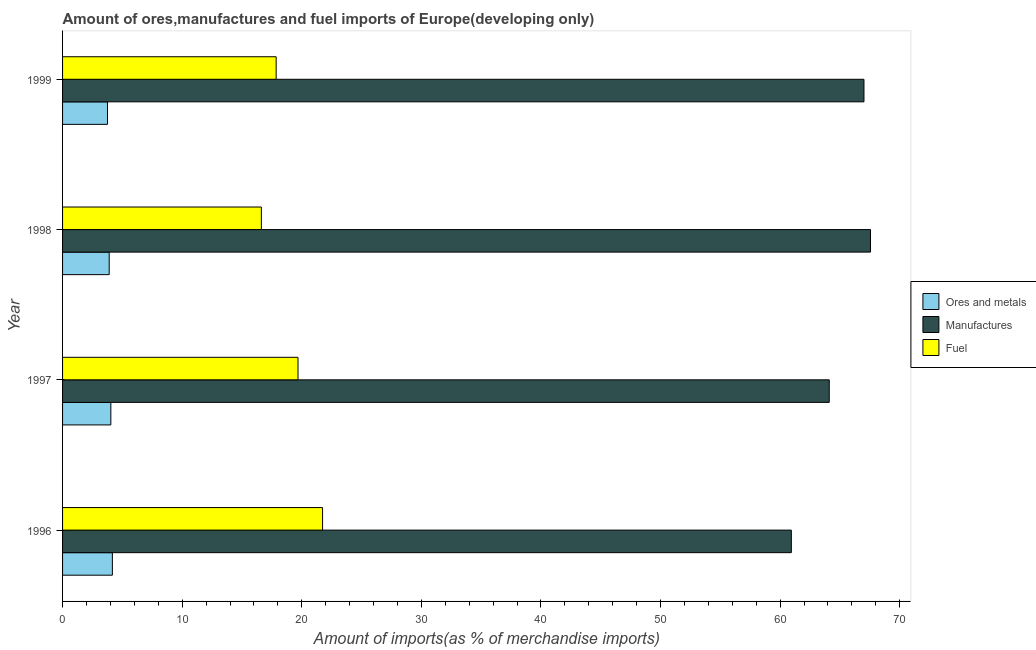How many different coloured bars are there?
Provide a succinct answer. 3. Are the number of bars per tick equal to the number of legend labels?
Provide a short and direct response. Yes. How many bars are there on the 2nd tick from the bottom?
Give a very brief answer. 3. What is the label of the 1st group of bars from the top?
Keep it short and to the point. 1999. What is the percentage of manufactures imports in 1999?
Make the answer very short. 67.01. Across all years, what is the maximum percentage of manufactures imports?
Your answer should be compact. 67.56. Across all years, what is the minimum percentage of ores and metals imports?
Give a very brief answer. 3.76. In which year was the percentage of manufactures imports maximum?
Provide a short and direct response. 1998. In which year was the percentage of manufactures imports minimum?
Keep it short and to the point. 1996. What is the total percentage of ores and metals imports in the graph?
Your answer should be compact. 15.86. What is the difference between the percentage of ores and metals imports in 1996 and that in 1998?
Your answer should be compact. 0.27. What is the difference between the percentage of ores and metals imports in 1998 and the percentage of fuel imports in 1997?
Make the answer very short. -15.79. What is the average percentage of manufactures imports per year?
Your answer should be compact. 64.9. In the year 1998, what is the difference between the percentage of manufactures imports and percentage of fuel imports?
Ensure brevity in your answer.  50.93. What is the ratio of the percentage of ores and metals imports in 1997 to that in 1999?
Offer a terse response. 1.07. Is the difference between the percentage of fuel imports in 1996 and 1997 greater than the difference between the percentage of ores and metals imports in 1996 and 1997?
Offer a terse response. Yes. What is the difference between the highest and the second highest percentage of fuel imports?
Make the answer very short. 2.05. What is the difference between the highest and the lowest percentage of manufactures imports?
Offer a terse response. 6.62. In how many years, is the percentage of ores and metals imports greater than the average percentage of ores and metals imports taken over all years?
Provide a short and direct response. 2. Is the sum of the percentage of manufactures imports in 1996 and 1997 greater than the maximum percentage of ores and metals imports across all years?
Your answer should be compact. Yes. What does the 1st bar from the top in 1997 represents?
Provide a short and direct response. Fuel. What does the 1st bar from the bottom in 1997 represents?
Provide a succinct answer. Ores and metals. How many years are there in the graph?
Provide a short and direct response. 4. Are the values on the major ticks of X-axis written in scientific E-notation?
Your response must be concise. No. Does the graph contain grids?
Offer a terse response. No. Where does the legend appear in the graph?
Offer a terse response. Center right. How are the legend labels stacked?
Provide a succinct answer. Vertical. What is the title of the graph?
Make the answer very short. Amount of ores,manufactures and fuel imports of Europe(developing only). What is the label or title of the X-axis?
Ensure brevity in your answer.  Amount of imports(as % of merchandise imports). What is the Amount of imports(as % of merchandise imports) of Ores and metals in 1996?
Your answer should be very brief. 4.16. What is the Amount of imports(as % of merchandise imports) of Manufactures in 1996?
Keep it short and to the point. 60.94. What is the Amount of imports(as % of merchandise imports) in Fuel in 1996?
Your response must be concise. 21.74. What is the Amount of imports(as % of merchandise imports) in Ores and metals in 1997?
Keep it short and to the point. 4.04. What is the Amount of imports(as % of merchandise imports) in Manufactures in 1997?
Give a very brief answer. 64.11. What is the Amount of imports(as % of merchandise imports) of Fuel in 1997?
Give a very brief answer. 19.69. What is the Amount of imports(as % of merchandise imports) in Ores and metals in 1998?
Your answer should be compact. 3.9. What is the Amount of imports(as % of merchandise imports) of Manufactures in 1998?
Give a very brief answer. 67.56. What is the Amount of imports(as % of merchandise imports) of Fuel in 1998?
Provide a succinct answer. 16.62. What is the Amount of imports(as % of merchandise imports) in Ores and metals in 1999?
Keep it short and to the point. 3.76. What is the Amount of imports(as % of merchandise imports) in Manufactures in 1999?
Offer a terse response. 67.01. What is the Amount of imports(as % of merchandise imports) in Fuel in 1999?
Ensure brevity in your answer.  17.86. Across all years, what is the maximum Amount of imports(as % of merchandise imports) of Ores and metals?
Offer a very short reply. 4.16. Across all years, what is the maximum Amount of imports(as % of merchandise imports) of Manufactures?
Your answer should be very brief. 67.56. Across all years, what is the maximum Amount of imports(as % of merchandise imports) of Fuel?
Your response must be concise. 21.74. Across all years, what is the minimum Amount of imports(as % of merchandise imports) in Ores and metals?
Your response must be concise. 3.76. Across all years, what is the minimum Amount of imports(as % of merchandise imports) in Manufactures?
Offer a very short reply. 60.94. Across all years, what is the minimum Amount of imports(as % of merchandise imports) in Fuel?
Make the answer very short. 16.62. What is the total Amount of imports(as % of merchandise imports) in Ores and metals in the graph?
Your response must be concise. 15.86. What is the total Amount of imports(as % of merchandise imports) in Manufactures in the graph?
Provide a succinct answer. 259.61. What is the total Amount of imports(as % of merchandise imports) of Fuel in the graph?
Your answer should be very brief. 75.91. What is the difference between the Amount of imports(as % of merchandise imports) in Ores and metals in 1996 and that in 1997?
Your response must be concise. 0.13. What is the difference between the Amount of imports(as % of merchandise imports) in Manufactures in 1996 and that in 1997?
Keep it short and to the point. -3.17. What is the difference between the Amount of imports(as % of merchandise imports) in Fuel in 1996 and that in 1997?
Ensure brevity in your answer.  2.05. What is the difference between the Amount of imports(as % of merchandise imports) of Ores and metals in 1996 and that in 1998?
Provide a short and direct response. 0.27. What is the difference between the Amount of imports(as % of merchandise imports) in Manufactures in 1996 and that in 1998?
Offer a terse response. -6.62. What is the difference between the Amount of imports(as % of merchandise imports) in Fuel in 1996 and that in 1998?
Your answer should be compact. 5.12. What is the difference between the Amount of imports(as % of merchandise imports) in Ores and metals in 1996 and that in 1999?
Make the answer very short. 0.41. What is the difference between the Amount of imports(as % of merchandise imports) of Manufactures in 1996 and that in 1999?
Give a very brief answer. -6.07. What is the difference between the Amount of imports(as % of merchandise imports) in Fuel in 1996 and that in 1999?
Make the answer very short. 3.88. What is the difference between the Amount of imports(as % of merchandise imports) in Ores and metals in 1997 and that in 1998?
Your answer should be very brief. 0.14. What is the difference between the Amount of imports(as % of merchandise imports) of Manufactures in 1997 and that in 1998?
Your answer should be compact. -3.45. What is the difference between the Amount of imports(as % of merchandise imports) of Fuel in 1997 and that in 1998?
Give a very brief answer. 3.06. What is the difference between the Amount of imports(as % of merchandise imports) in Ores and metals in 1997 and that in 1999?
Provide a succinct answer. 0.28. What is the difference between the Amount of imports(as % of merchandise imports) in Manufactures in 1997 and that in 1999?
Your response must be concise. -2.9. What is the difference between the Amount of imports(as % of merchandise imports) of Fuel in 1997 and that in 1999?
Your answer should be very brief. 1.83. What is the difference between the Amount of imports(as % of merchandise imports) in Ores and metals in 1998 and that in 1999?
Your answer should be compact. 0.14. What is the difference between the Amount of imports(as % of merchandise imports) in Manufactures in 1998 and that in 1999?
Keep it short and to the point. 0.55. What is the difference between the Amount of imports(as % of merchandise imports) in Fuel in 1998 and that in 1999?
Your response must be concise. -1.24. What is the difference between the Amount of imports(as % of merchandise imports) of Ores and metals in 1996 and the Amount of imports(as % of merchandise imports) of Manufactures in 1997?
Provide a succinct answer. -59.94. What is the difference between the Amount of imports(as % of merchandise imports) of Ores and metals in 1996 and the Amount of imports(as % of merchandise imports) of Fuel in 1997?
Your answer should be very brief. -15.52. What is the difference between the Amount of imports(as % of merchandise imports) in Manufactures in 1996 and the Amount of imports(as % of merchandise imports) in Fuel in 1997?
Provide a succinct answer. 41.25. What is the difference between the Amount of imports(as % of merchandise imports) of Ores and metals in 1996 and the Amount of imports(as % of merchandise imports) of Manufactures in 1998?
Offer a terse response. -63.39. What is the difference between the Amount of imports(as % of merchandise imports) of Ores and metals in 1996 and the Amount of imports(as % of merchandise imports) of Fuel in 1998?
Ensure brevity in your answer.  -12.46. What is the difference between the Amount of imports(as % of merchandise imports) of Manufactures in 1996 and the Amount of imports(as % of merchandise imports) of Fuel in 1998?
Offer a very short reply. 44.31. What is the difference between the Amount of imports(as % of merchandise imports) of Ores and metals in 1996 and the Amount of imports(as % of merchandise imports) of Manufactures in 1999?
Provide a succinct answer. -62.84. What is the difference between the Amount of imports(as % of merchandise imports) of Ores and metals in 1996 and the Amount of imports(as % of merchandise imports) of Fuel in 1999?
Ensure brevity in your answer.  -13.7. What is the difference between the Amount of imports(as % of merchandise imports) in Manufactures in 1996 and the Amount of imports(as % of merchandise imports) in Fuel in 1999?
Your answer should be compact. 43.08. What is the difference between the Amount of imports(as % of merchandise imports) in Ores and metals in 1997 and the Amount of imports(as % of merchandise imports) in Manufactures in 1998?
Give a very brief answer. -63.52. What is the difference between the Amount of imports(as % of merchandise imports) of Ores and metals in 1997 and the Amount of imports(as % of merchandise imports) of Fuel in 1998?
Provide a short and direct response. -12.59. What is the difference between the Amount of imports(as % of merchandise imports) of Manufactures in 1997 and the Amount of imports(as % of merchandise imports) of Fuel in 1998?
Keep it short and to the point. 47.48. What is the difference between the Amount of imports(as % of merchandise imports) of Ores and metals in 1997 and the Amount of imports(as % of merchandise imports) of Manufactures in 1999?
Your answer should be very brief. -62.97. What is the difference between the Amount of imports(as % of merchandise imports) in Ores and metals in 1997 and the Amount of imports(as % of merchandise imports) in Fuel in 1999?
Offer a very short reply. -13.82. What is the difference between the Amount of imports(as % of merchandise imports) of Manufactures in 1997 and the Amount of imports(as % of merchandise imports) of Fuel in 1999?
Make the answer very short. 46.25. What is the difference between the Amount of imports(as % of merchandise imports) in Ores and metals in 1998 and the Amount of imports(as % of merchandise imports) in Manufactures in 1999?
Offer a terse response. -63.11. What is the difference between the Amount of imports(as % of merchandise imports) in Ores and metals in 1998 and the Amount of imports(as % of merchandise imports) in Fuel in 1999?
Give a very brief answer. -13.96. What is the difference between the Amount of imports(as % of merchandise imports) in Manufactures in 1998 and the Amount of imports(as % of merchandise imports) in Fuel in 1999?
Your response must be concise. 49.7. What is the average Amount of imports(as % of merchandise imports) of Ores and metals per year?
Provide a succinct answer. 3.96. What is the average Amount of imports(as % of merchandise imports) of Manufactures per year?
Give a very brief answer. 64.9. What is the average Amount of imports(as % of merchandise imports) in Fuel per year?
Offer a terse response. 18.98. In the year 1996, what is the difference between the Amount of imports(as % of merchandise imports) of Ores and metals and Amount of imports(as % of merchandise imports) of Manufactures?
Your answer should be very brief. -56.77. In the year 1996, what is the difference between the Amount of imports(as % of merchandise imports) in Ores and metals and Amount of imports(as % of merchandise imports) in Fuel?
Your answer should be compact. -17.57. In the year 1996, what is the difference between the Amount of imports(as % of merchandise imports) in Manufactures and Amount of imports(as % of merchandise imports) in Fuel?
Offer a terse response. 39.2. In the year 1997, what is the difference between the Amount of imports(as % of merchandise imports) in Ores and metals and Amount of imports(as % of merchandise imports) in Manufactures?
Keep it short and to the point. -60.07. In the year 1997, what is the difference between the Amount of imports(as % of merchandise imports) in Ores and metals and Amount of imports(as % of merchandise imports) in Fuel?
Provide a succinct answer. -15.65. In the year 1997, what is the difference between the Amount of imports(as % of merchandise imports) of Manufactures and Amount of imports(as % of merchandise imports) of Fuel?
Keep it short and to the point. 44.42. In the year 1998, what is the difference between the Amount of imports(as % of merchandise imports) of Ores and metals and Amount of imports(as % of merchandise imports) of Manufactures?
Offer a very short reply. -63.66. In the year 1998, what is the difference between the Amount of imports(as % of merchandise imports) in Ores and metals and Amount of imports(as % of merchandise imports) in Fuel?
Provide a succinct answer. -12.72. In the year 1998, what is the difference between the Amount of imports(as % of merchandise imports) of Manufactures and Amount of imports(as % of merchandise imports) of Fuel?
Offer a very short reply. 50.93. In the year 1999, what is the difference between the Amount of imports(as % of merchandise imports) in Ores and metals and Amount of imports(as % of merchandise imports) in Manufactures?
Your answer should be very brief. -63.25. In the year 1999, what is the difference between the Amount of imports(as % of merchandise imports) of Ores and metals and Amount of imports(as % of merchandise imports) of Fuel?
Keep it short and to the point. -14.1. In the year 1999, what is the difference between the Amount of imports(as % of merchandise imports) of Manufactures and Amount of imports(as % of merchandise imports) of Fuel?
Provide a succinct answer. 49.15. What is the ratio of the Amount of imports(as % of merchandise imports) in Ores and metals in 1996 to that in 1997?
Keep it short and to the point. 1.03. What is the ratio of the Amount of imports(as % of merchandise imports) in Manufactures in 1996 to that in 1997?
Keep it short and to the point. 0.95. What is the ratio of the Amount of imports(as % of merchandise imports) in Fuel in 1996 to that in 1997?
Provide a short and direct response. 1.1. What is the ratio of the Amount of imports(as % of merchandise imports) of Ores and metals in 1996 to that in 1998?
Keep it short and to the point. 1.07. What is the ratio of the Amount of imports(as % of merchandise imports) of Manufactures in 1996 to that in 1998?
Keep it short and to the point. 0.9. What is the ratio of the Amount of imports(as % of merchandise imports) of Fuel in 1996 to that in 1998?
Give a very brief answer. 1.31. What is the ratio of the Amount of imports(as % of merchandise imports) in Ores and metals in 1996 to that in 1999?
Ensure brevity in your answer.  1.11. What is the ratio of the Amount of imports(as % of merchandise imports) of Manufactures in 1996 to that in 1999?
Keep it short and to the point. 0.91. What is the ratio of the Amount of imports(as % of merchandise imports) in Fuel in 1996 to that in 1999?
Provide a short and direct response. 1.22. What is the ratio of the Amount of imports(as % of merchandise imports) in Ores and metals in 1997 to that in 1998?
Give a very brief answer. 1.04. What is the ratio of the Amount of imports(as % of merchandise imports) of Manufactures in 1997 to that in 1998?
Provide a succinct answer. 0.95. What is the ratio of the Amount of imports(as % of merchandise imports) in Fuel in 1997 to that in 1998?
Offer a very short reply. 1.18. What is the ratio of the Amount of imports(as % of merchandise imports) in Ores and metals in 1997 to that in 1999?
Your response must be concise. 1.07. What is the ratio of the Amount of imports(as % of merchandise imports) of Manufactures in 1997 to that in 1999?
Keep it short and to the point. 0.96. What is the ratio of the Amount of imports(as % of merchandise imports) in Fuel in 1997 to that in 1999?
Your response must be concise. 1.1. What is the ratio of the Amount of imports(as % of merchandise imports) of Ores and metals in 1998 to that in 1999?
Offer a terse response. 1.04. What is the ratio of the Amount of imports(as % of merchandise imports) in Manufactures in 1998 to that in 1999?
Offer a terse response. 1.01. What is the ratio of the Amount of imports(as % of merchandise imports) of Fuel in 1998 to that in 1999?
Your answer should be very brief. 0.93. What is the difference between the highest and the second highest Amount of imports(as % of merchandise imports) in Ores and metals?
Your answer should be compact. 0.13. What is the difference between the highest and the second highest Amount of imports(as % of merchandise imports) in Manufactures?
Provide a short and direct response. 0.55. What is the difference between the highest and the second highest Amount of imports(as % of merchandise imports) of Fuel?
Keep it short and to the point. 2.05. What is the difference between the highest and the lowest Amount of imports(as % of merchandise imports) in Ores and metals?
Your response must be concise. 0.41. What is the difference between the highest and the lowest Amount of imports(as % of merchandise imports) in Manufactures?
Ensure brevity in your answer.  6.62. What is the difference between the highest and the lowest Amount of imports(as % of merchandise imports) of Fuel?
Ensure brevity in your answer.  5.12. 